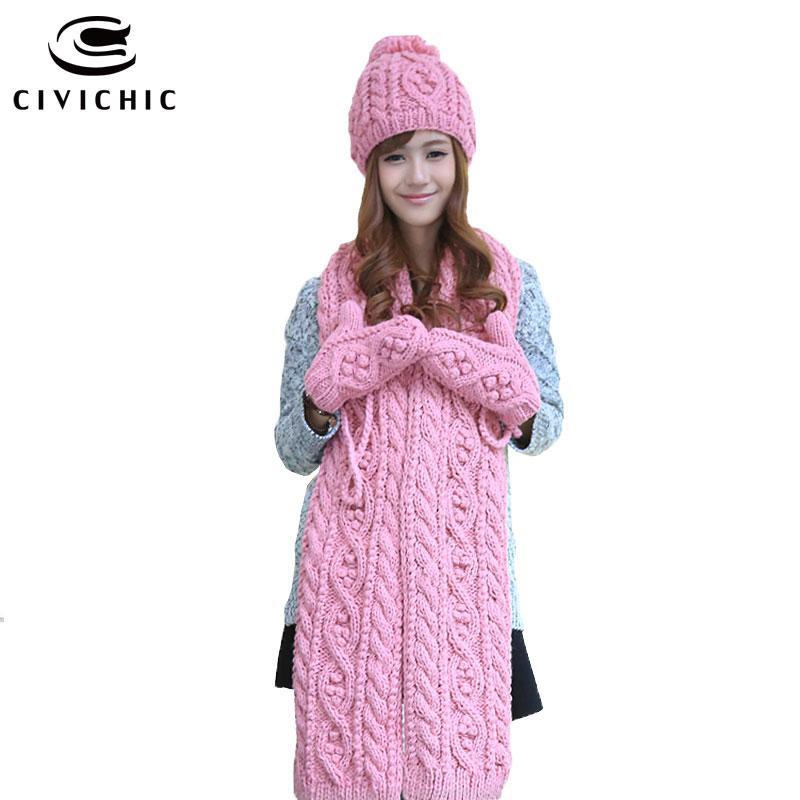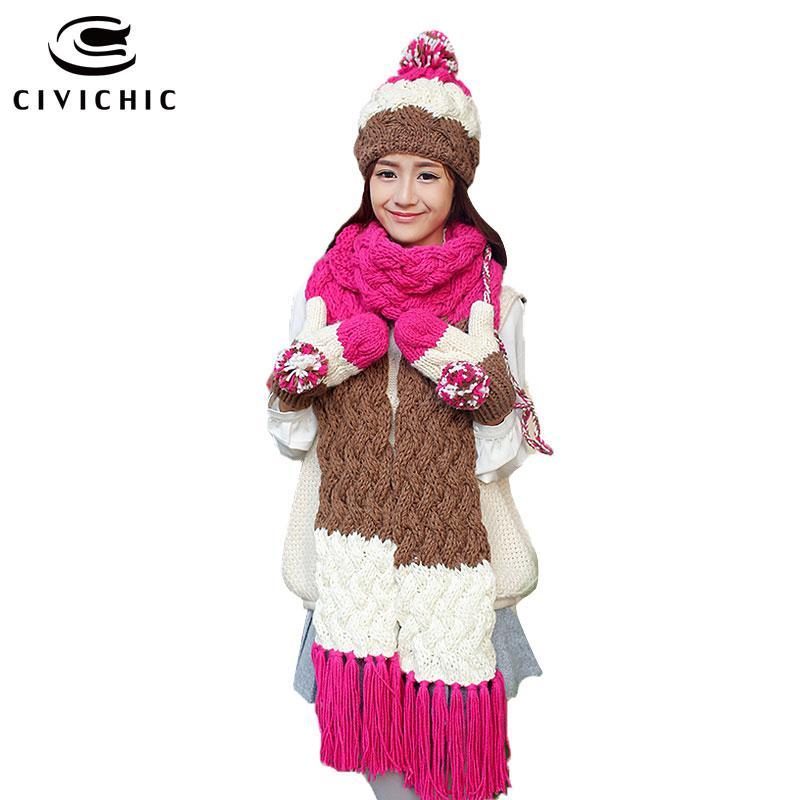The first image is the image on the left, the second image is the image on the right. For the images displayed, is the sentence "One woman is wearing a large dark pink, brown and white scarf with matching gloves and hat that has a pompom." factually correct? Answer yes or no. Yes. The first image is the image on the left, the second image is the image on the right. Analyze the images presented: Is the assertion "There is a girl with her mouth covered." valid? Answer yes or no. No. 